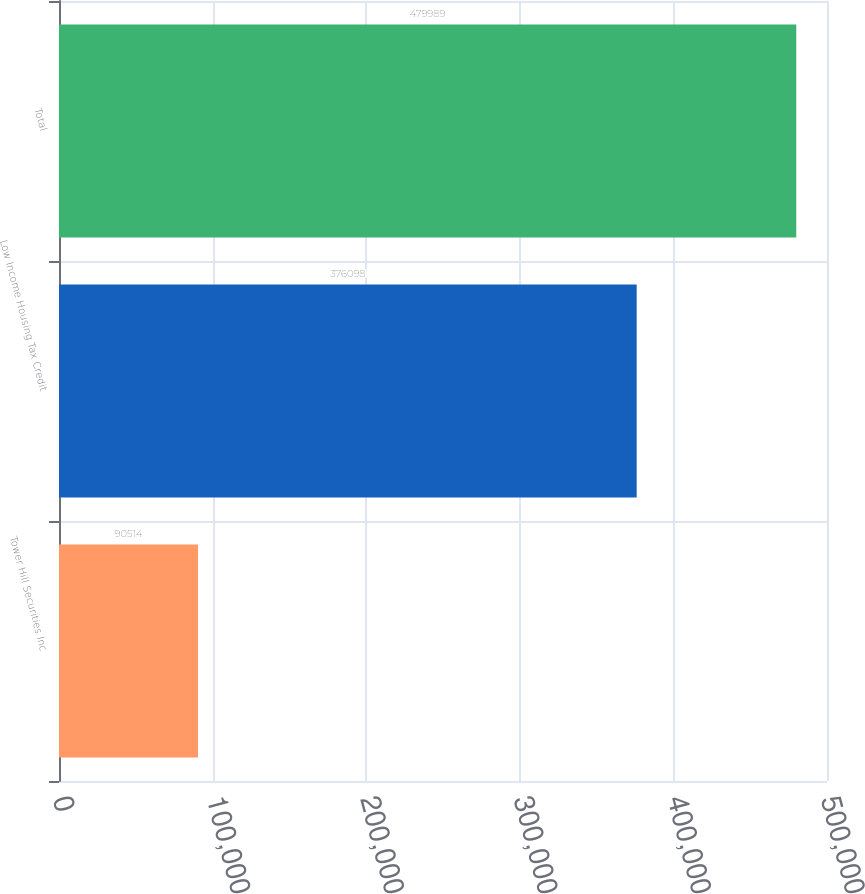Convert chart. <chart><loc_0><loc_0><loc_500><loc_500><bar_chart><fcel>Tower Hill Securities Inc<fcel>Low Income Housing Tax Credit<fcel>Total<nl><fcel>90514<fcel>376098<fcel>479989<nl></chart> 